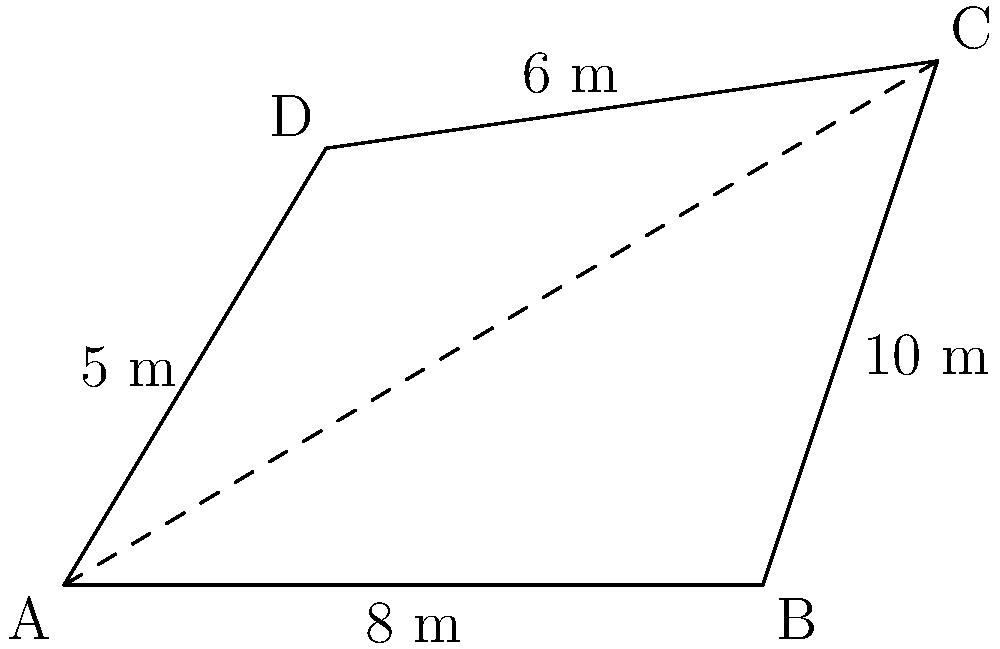As a retired history teacher, you've decided to measure an irregular field for a local community garden project. The field is represented by the quadrilateral ABCD in the diagram. Given that AB = 8 m, BC = 10 m, CD = 6 m, and AD = 5 m, calculate the area of the field using trigonometric functions. To find the area of the irregular quadrilateral, we can split it into two triangles and use the trigonometric area formula:

Area of a triangle = $\frac{1}{2} \cdot ab \cdot \sin(C)$, where $a$ and $b$ are side lengths and $C$ is the angle between them.

Step 1: Find the diagonal AC using the law of cosines in triangle ABC:
$AC^2 = AB^2 + BC^2 - 2(AB)(BC)\cos(\angle ABC)$
$AC^2 = 8^2 + 10^2 - 2(8)(10)\cos(\angle ABC)$

Step 2: Use the law of cosines in triangle ACD to find $\cos(\angle ACD)$:
$AC^2 = AD^2 + CD^2 - 2(AD)(CD)\cos(\angle ACD)$
$\cos(\angle ACD) = \frac{AD^2 + CD^2 - AC^2}{2(AD)(CD)}$

Step 3: Calculate the areas of triangles ABC and ACD:
Area of ABC = $\frac{1}{2} \cdot AB \cdot BC \cdot \sin(\angle ABC)$
Area of ACD = $\frac{1}{2} \cdot AD \cdot CD \cdot \sin(\angle ACD)$

Step 4: Add the areas of the two triangles to get the total area of the quadrilateral.

Total Area = Area of ABC + Area of ACD

Due to the complexity of the calculations, it's best to use a calculator or computer program to find the exact numerical result.
Answer: Area ≈ 41.23 m² 